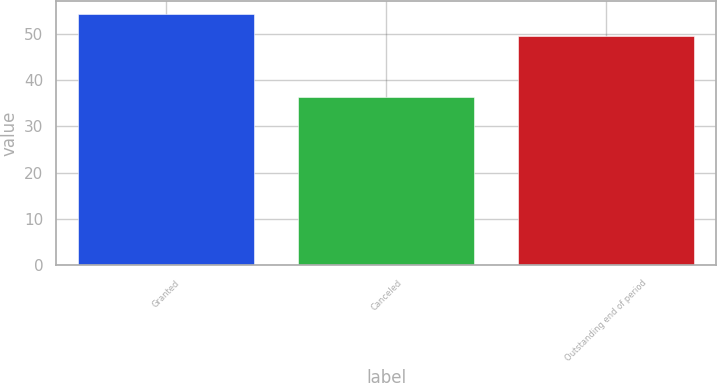Convert chart to OTSL. <chart><loc_0><loc_0><loc_500><loc_500><bar_chart><fcel>Granted<fcel>Canceled<fcel>Outstanding end of period<nl><fcel>54.3<fcel>36.4<fcel>49.53<nl></chart> 